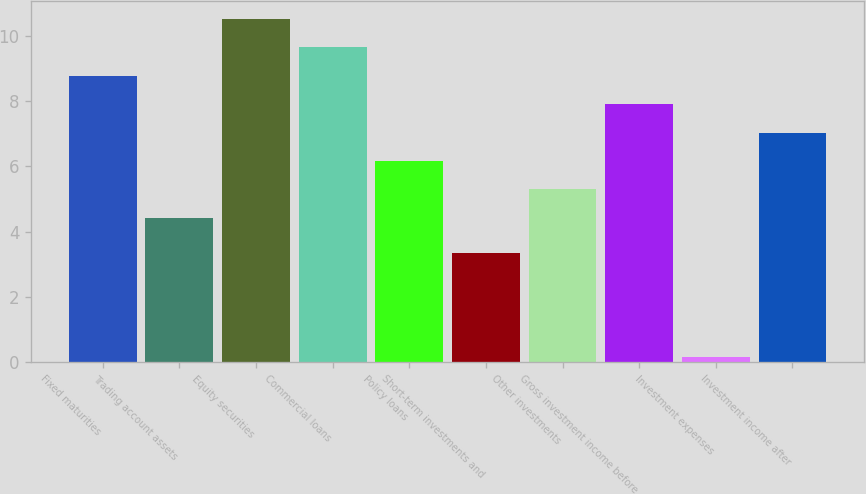Convert chart to OTSL. <chart><loc_0><loc_0><loc_500><loc_500><bar_chart><fcel>Fixed maturities<fcel>Trading account assets<fcel>Equity securities<fcel>Commercial loans<fcel>Policy loans<fcel>Short-term investments and<fcel>Other investments<fcel>Gross investment income before<fcel>Investment expenses<fcel>Investment income after<nl><fcel>8.79<fcel>4.43<fcel>10.54<fcel>9.66<fcel>6.17<fcel>3.35<fcel>5.3<fcel>7.92<fcel>0.16<fcel>7.04<nl></chart> 